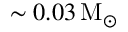Convert formula to latex. <formula><loc_0><loc_0><loc_500><loc_500>\sim 0 . 0 3 \, M _ { \odot }</formula> 